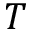Convert formula to latex. <formula><loc_0><loc_0><loc_500><loc_500>T</formula> 